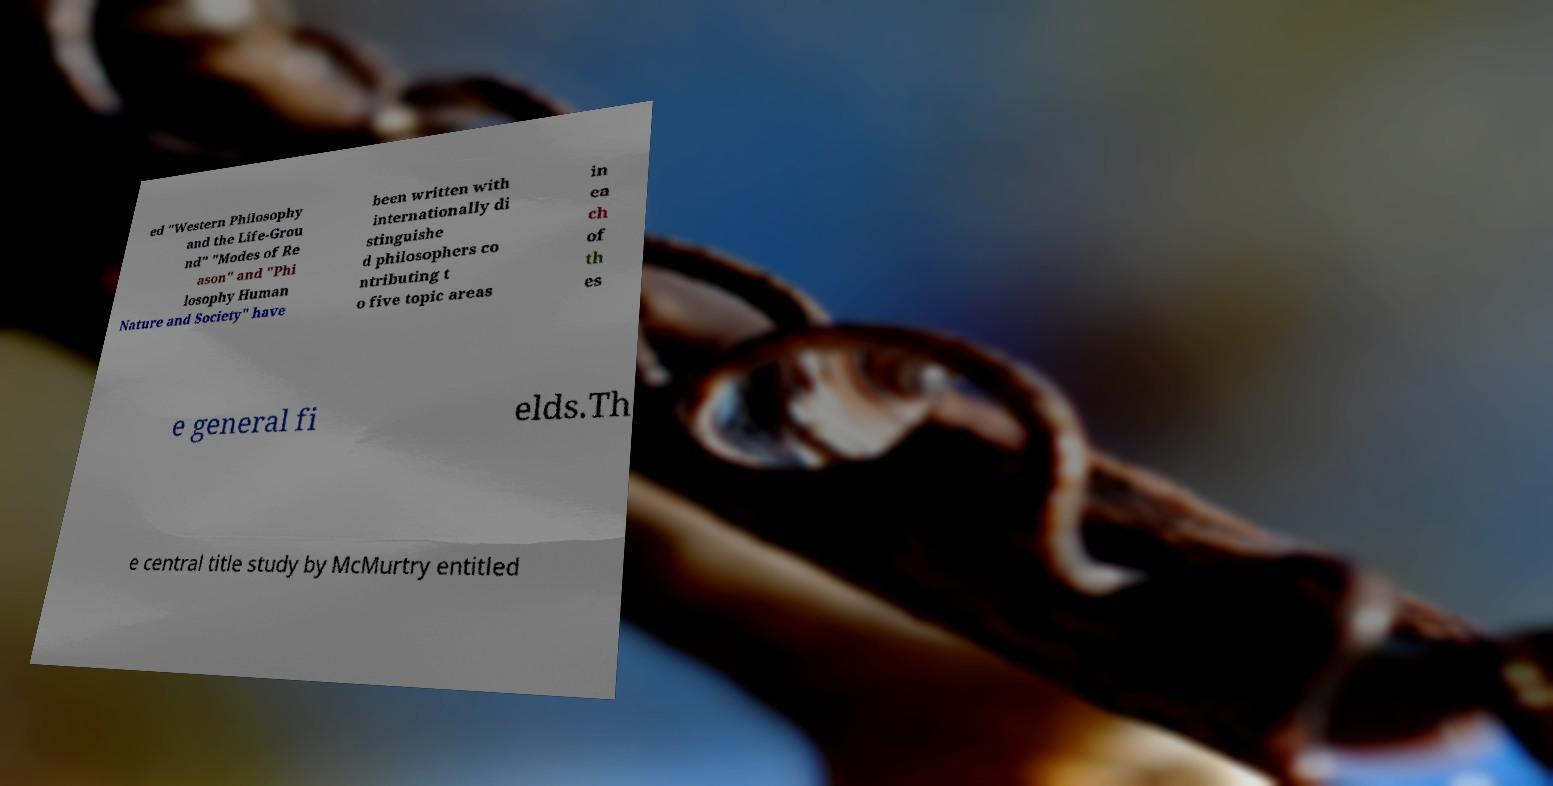There's text embedded in this image that I need extracted. Can you transcribe it verbatim? ed "Western Philosophy and the Life-Grou nd" "Modes of Re ason" and "Phi losophy Human Nature and Society" have been written with internationally di stinguishe d philosophers co ntributing t o five topic areas in ea ch of th es e general fi elds.Th e central title study by McMurtry entitled 